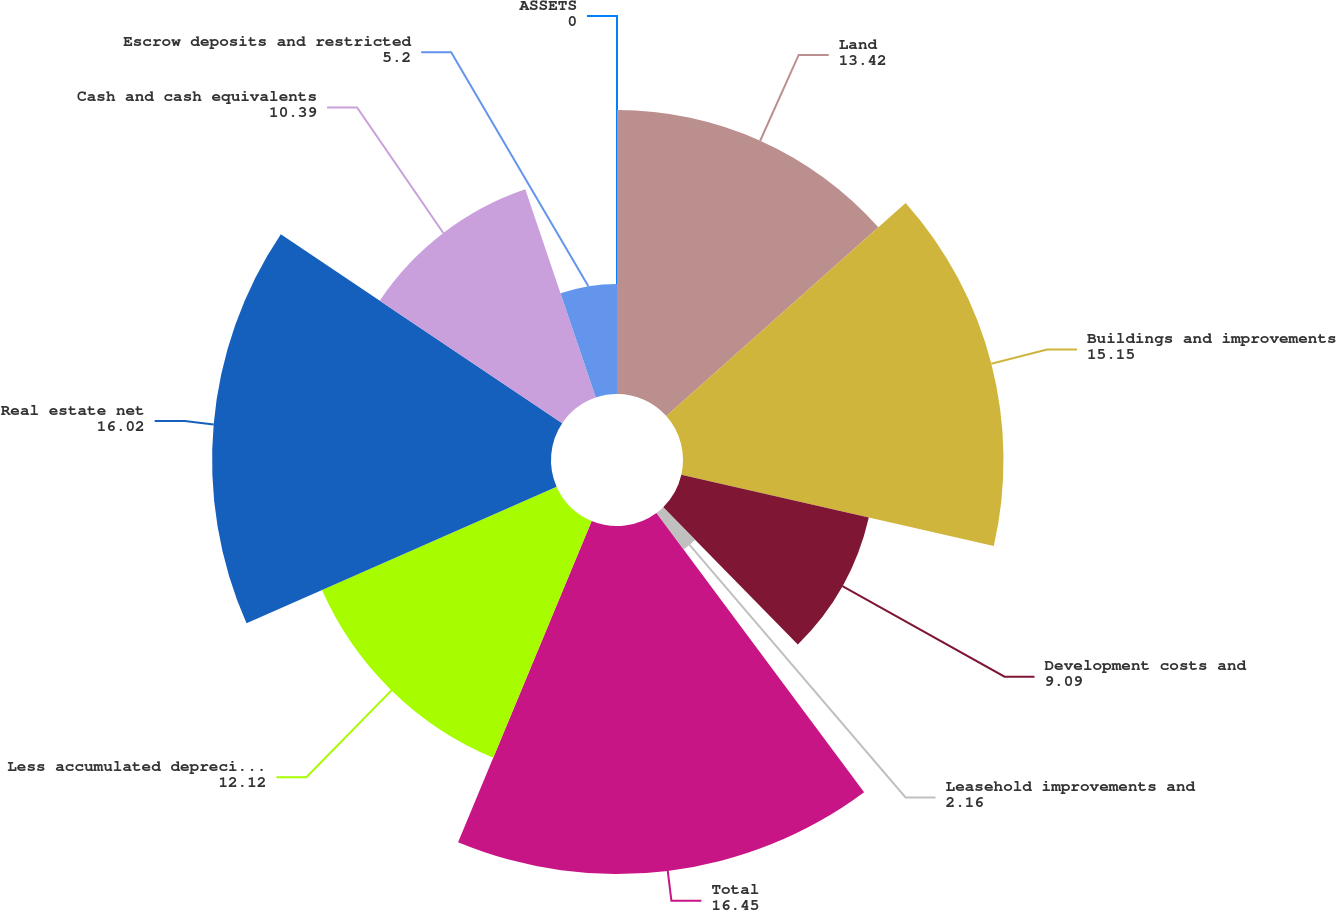<chart> <loc_0><loc_0><loc_500><loc_500><pie_chart><fcel>ASSETS<fcel>Land<fcel>Buildings and improvements<fcel>Development costs and<fcel>Leasehold improvements and<fcel>Total<fcel>Less accumulated depreciation<fcel>Real estate net<fcel>Cash and cash equivalents<fcel>Escrow deposits and restricted<nl><fcel>0.0%<fcel>13.42%<fcel>15.15%<fcel>9.09%<fcel>2.16%<fcel>16.45%<fcel>12.12%<fcel>16.02%<fcel>10.39%<fcel>5.2%<nl></chart> 